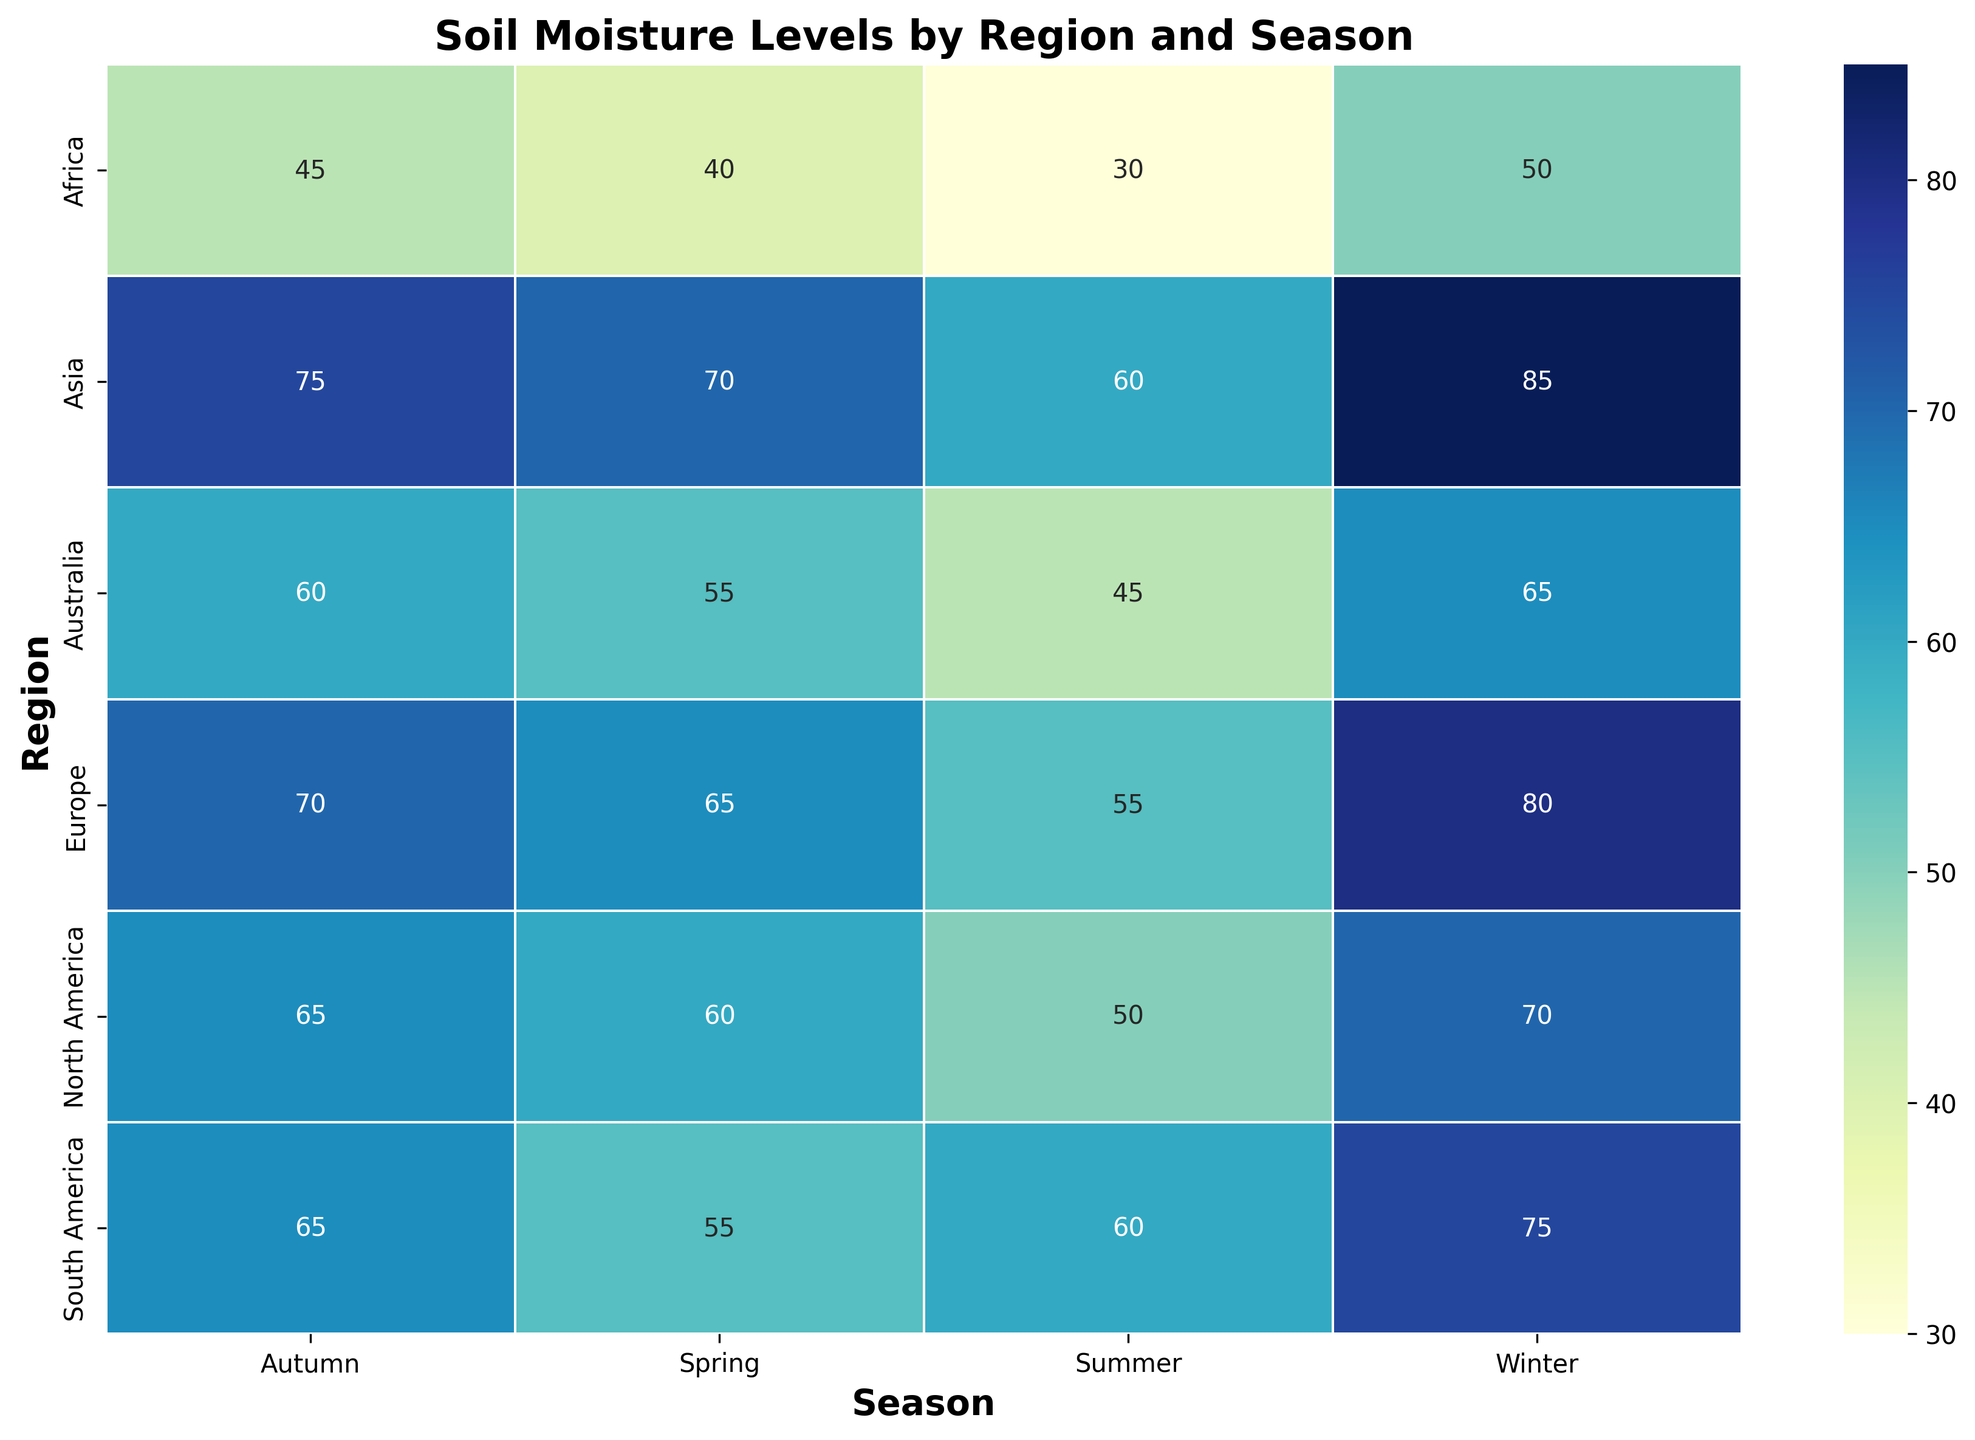Which region shows the highest soil moisture level in winter? Find the row corresponding to winter and look for the highest value. Asia has the highest soil moisture level in winter at 85.
Answer: Asia Which season has the lowest soil moisture level in Africa? Look for the column corresponding to Africa and identify the lowest value, which is in Summer at 30.
Answer: Summer Compare soil moisture in summer between Europe and North America. Which one is higher? Identify the summer values for both regions: Europe (55) and North America (50). Europe has a higher soil moisture level in summer.
Answer: Europe What is the average soil moisture level in South America across the seasons? Sum the soil moisture values for South America (55 + 60 + 65 + 75 = 255) and divide by the number of seasons (4). The average is 255 / 4 = 63.75.
Answer: 63.75 Which region experiences the smallest change in soil moisture between summer and winter? Calculate the difference in soil moisture between summer and winter for each region and find the smallest: North America (70 - 50 = 20), South America (75 - 60 = 15), Europe (80 - 55 = 25), Asia (85 - 60 = 25), Africa (50 - 30 = 20), Australia (65 - 45 = 20). South America has the smallest change, which is 15.
Answer: South America In which season is the soil moisture level most consistent across regions? Look at the columns for each season and analyze the range (difference between the highest and lowest soil moisture levels). Spring: 70 - 40 = 30, Summer: 60 - 30 = 30, Autumn: 75 - 45 = 30, Winter: 85 - 50 = 35. The most consistent season is Spring, Summer, and Autumn, all with a range of 30.
Answer: Spring, Summer, and Autumn What is the soil moisture difference between spring and autumn in Australia? Subtract the soil moisture level in spring (55) from that in autumn (60). The difference is 60 - 55 = 5.
Answer: 5 